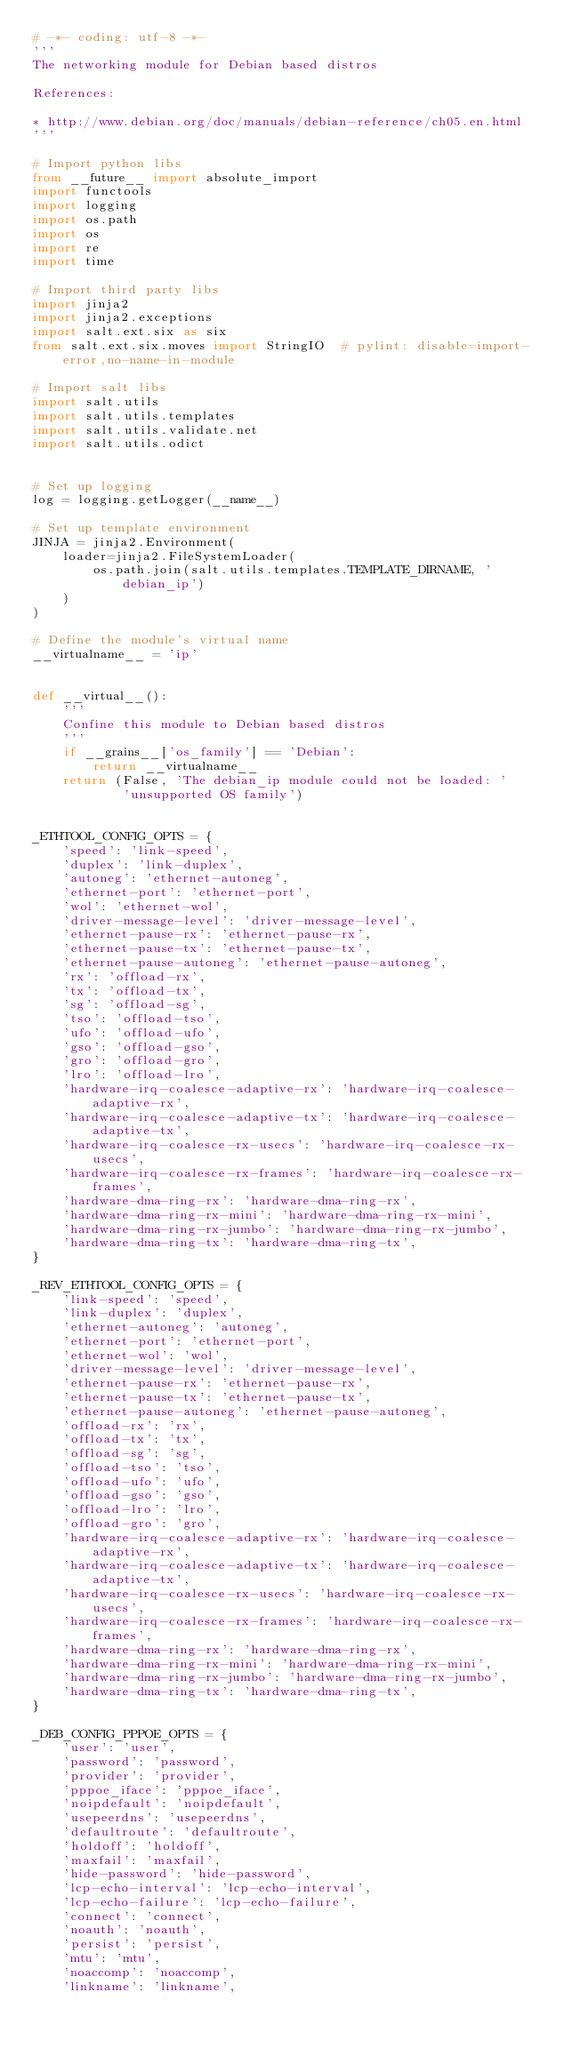Convert code to text. <code><loc_0><loc_0><loc_500><loc_500><_Python_># -*- coding: utf-8 -*-
'''
The networking module for Debian based distros

References:

* http://www.debian.org/doc/manuals/debian-reference/ch05.en.html
'''

# Import python libs
from __future__ import absolute_import
import functools
import logging
import os.path
import os
import re
import time

# Import third party libs
import jinja2
import jinja2.exceptions
import salt.ext.six as six
from salt.ext.six.moves import StringIO  # pylint: disable=import-error,no-name-in-module

# Import salt libs
import salt.utils
import salt.utils.templates
import salt.utils.validate.net
import salt.utils.odict


# Set up logging
log = logging.getLogger(__name__)

# Set up template environment
JINJA = jinja2.Environment(
    loader=jinja2.FileSystemLoader(
        os.path.join(salt.utils.templates.TEMPLATE_DIRNAME, 'debian_ip')
    )
)

# Define the module's virtual name
__virtualname__ = 'ip'


def __virtual__():
    '''
    Confine this module to Debian based distros
    '''
    if __grains__['os_family'] == 'Debian':
        return __virtualname__
    return (False, 'The debian_ip module could not be loaded: '
            'unsupported OS family')


_ETHTOOL_CONFIG_OPTS = {
    'speed': 'link-speed',
    'duplex': 'link-duplex',
    'autoneg': 'ethernet-autoneg',
    'ethernet-port': 'ethernet-port',
    'wol': 'ethernet-wol',
    'driver-message-level': 'driver-message-level',
    'ethernet-pause-rx': 'ethernet-pause-rx',
    'ethernet-pause-tx': 'ethernet-pause-tx',
    'ethernet-pause-autoneg': 'ethernet-pause-autoneg',
    'rx': 'offload-rx',
    'tx': 'offload-tx',
    'sg': 'offload-sg',
    'tso': 'offload-tso',
    'ufo': 'offload-ufo',
    'gso': 'offload-gso',
    'gro': 'offload-gro',
    'lro': 'offload-lro',
    'hardware-irq-coalesce-adaptive-rx': 'hardware-irq-coalesce-adaptive-rx',
    'hardware-irq-coalesce-adaptive-tx': 'hardware-irq-coalesce-adaptive-tx',
    'hardware-irq-coalesce-rx-usecs': 'hardware-irq-coalesce-rx-usecs',
    'hardware-irq-coalesce-rx-frames': 'hardware-irq-coalesce-rx-frames',
    'hardware-dma-ring-rx': 'hardware-dma-ring-rx',
    'hardware-dma-ring-rx-mini': 'hardware-dma-ring-rx-mini',
    'hardware-dma-ring-rx-jumbo': 'hardware-dma-ring-rx-jumbo',
    'hardware-dma-ring-tx': 'hardware-dma-ring-tx',
}

_REV_ETHTOOL_CONFIG_OPTS = {
    'link-speed': 'speed',
    'link-duplex': 'duplex',
    'ethernet-autoneg': 'autoneg',
    'ethernet-port': 'ethernet-port',
    'ethernet-wol': 'wol',
    'driver-message-level': 'driver-message-level',
    'ethernet-pause-rx': 'ethernet-pause-rx',
    'ethernet-pause-tx': 'ethernet-pause-tx',
    'ethernet-pause-autoneg': 'ethernet-pause-autoneg',
    'offload-rx': 'rx',
    'offload-tx': 'tx',
    'offload-sg': 'sg',
    'offload-tso': 'tso',
    'offload-ufo': 'ufo',
    'offload-gso': 'gso',
    'offload-lro': 'lro',
    'offload-gro': 'gro',
    'hardware-irq-coalesce-adaptive-rx': 'hardware-irq-coalesce-adaptive-rx',
    'hardware-irq-coalesce-adaptive-tx': 'hardware-irq-coalesce-adaptive-tx',
    'hardware-irq-coalesce-rx-usecs': 'hardware-irq-coalesce-rx-usecs',
    'hardware-irq-coalesce-rx-frames': 'hardware-irq-coalesce-rx-frames',
    'hardware-dma-ring-rx': 'hardware-dma-ring-rx',
    'hardware-dma-ring-rx-mini': 'hardware-dma-ring-rx-mini',
    'hardware-dma-ring-rx-jumbo': 'hardware-dma-ring-rx-jumbo',
    'hardware-dma-ring-tx': 'hardware-dma-ring-tx',
}

_DEB_CONFIG_PPPOE_OPTS = {
    'user': 'user',
    'password': 'password',
    'provider': 'provider',
    'pppoe_iface': 'pppoe_iface',
    'noipdefault': 'noipdefault',
    'usepeerdns': 'usepeerdns',
    'defaultroute': 'defaultroute',
    'holdoff': 'holdoff',
    'maxfail': 'maxfail',
    'hide-password': 'hide-password',
    'lcp-echo-interval': 'lcp-echo-interval',
    'lcp-echo-failure': 'lcp-echo-failure',
    'connect': 'connect',
    'noauth': 'noauth',
    'persist': 'persist',
    'mtu': 'mtu',
    'noaccomp': 'noaccomp',
    'linkname': 'linkname',</code> 